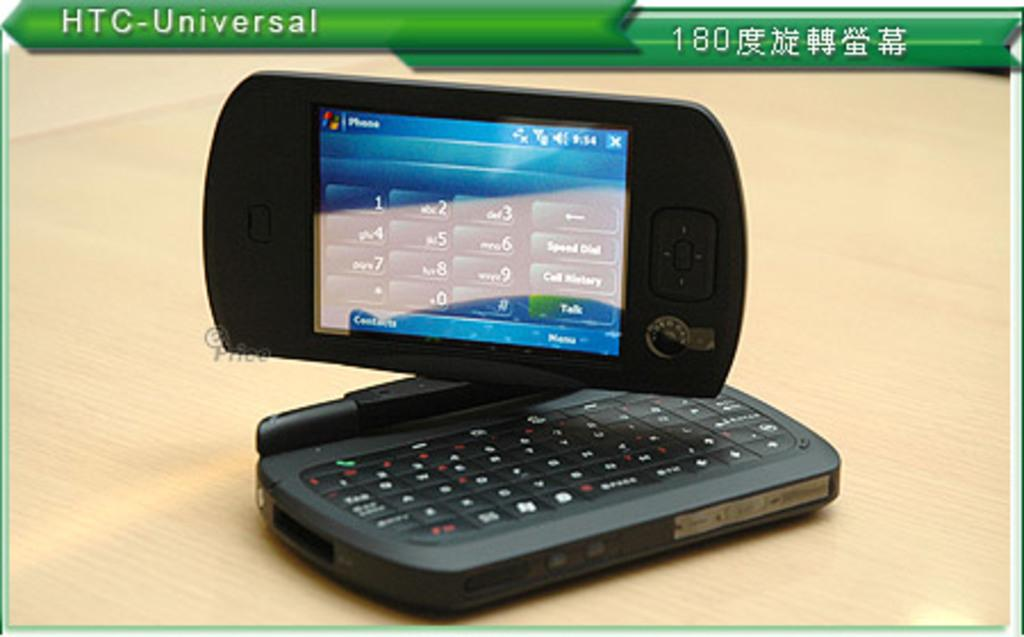<image>
Write a terse but informative summary of the picture. "HTC Universal" appears on a green background above a phone with a swivel screen. 